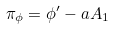<formula> <loc_0><loc_0><loc_500><loc_500>\pi _ { \phi } = \phi ^ { \prime } - a A _ { 1 }</formula> 